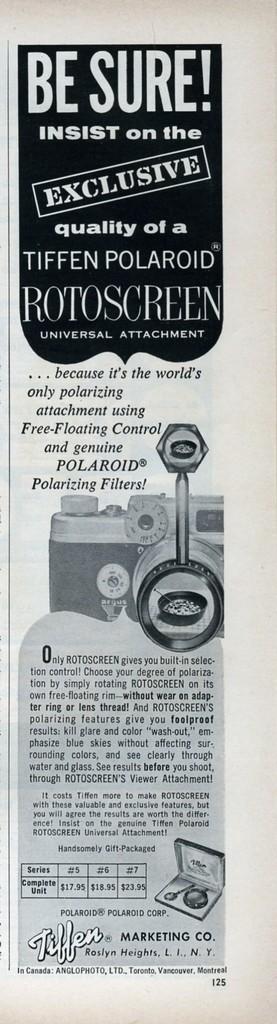Describe this image in one or two sentences. In this picture I can see a paper, there are photos, words and numbers on it. 